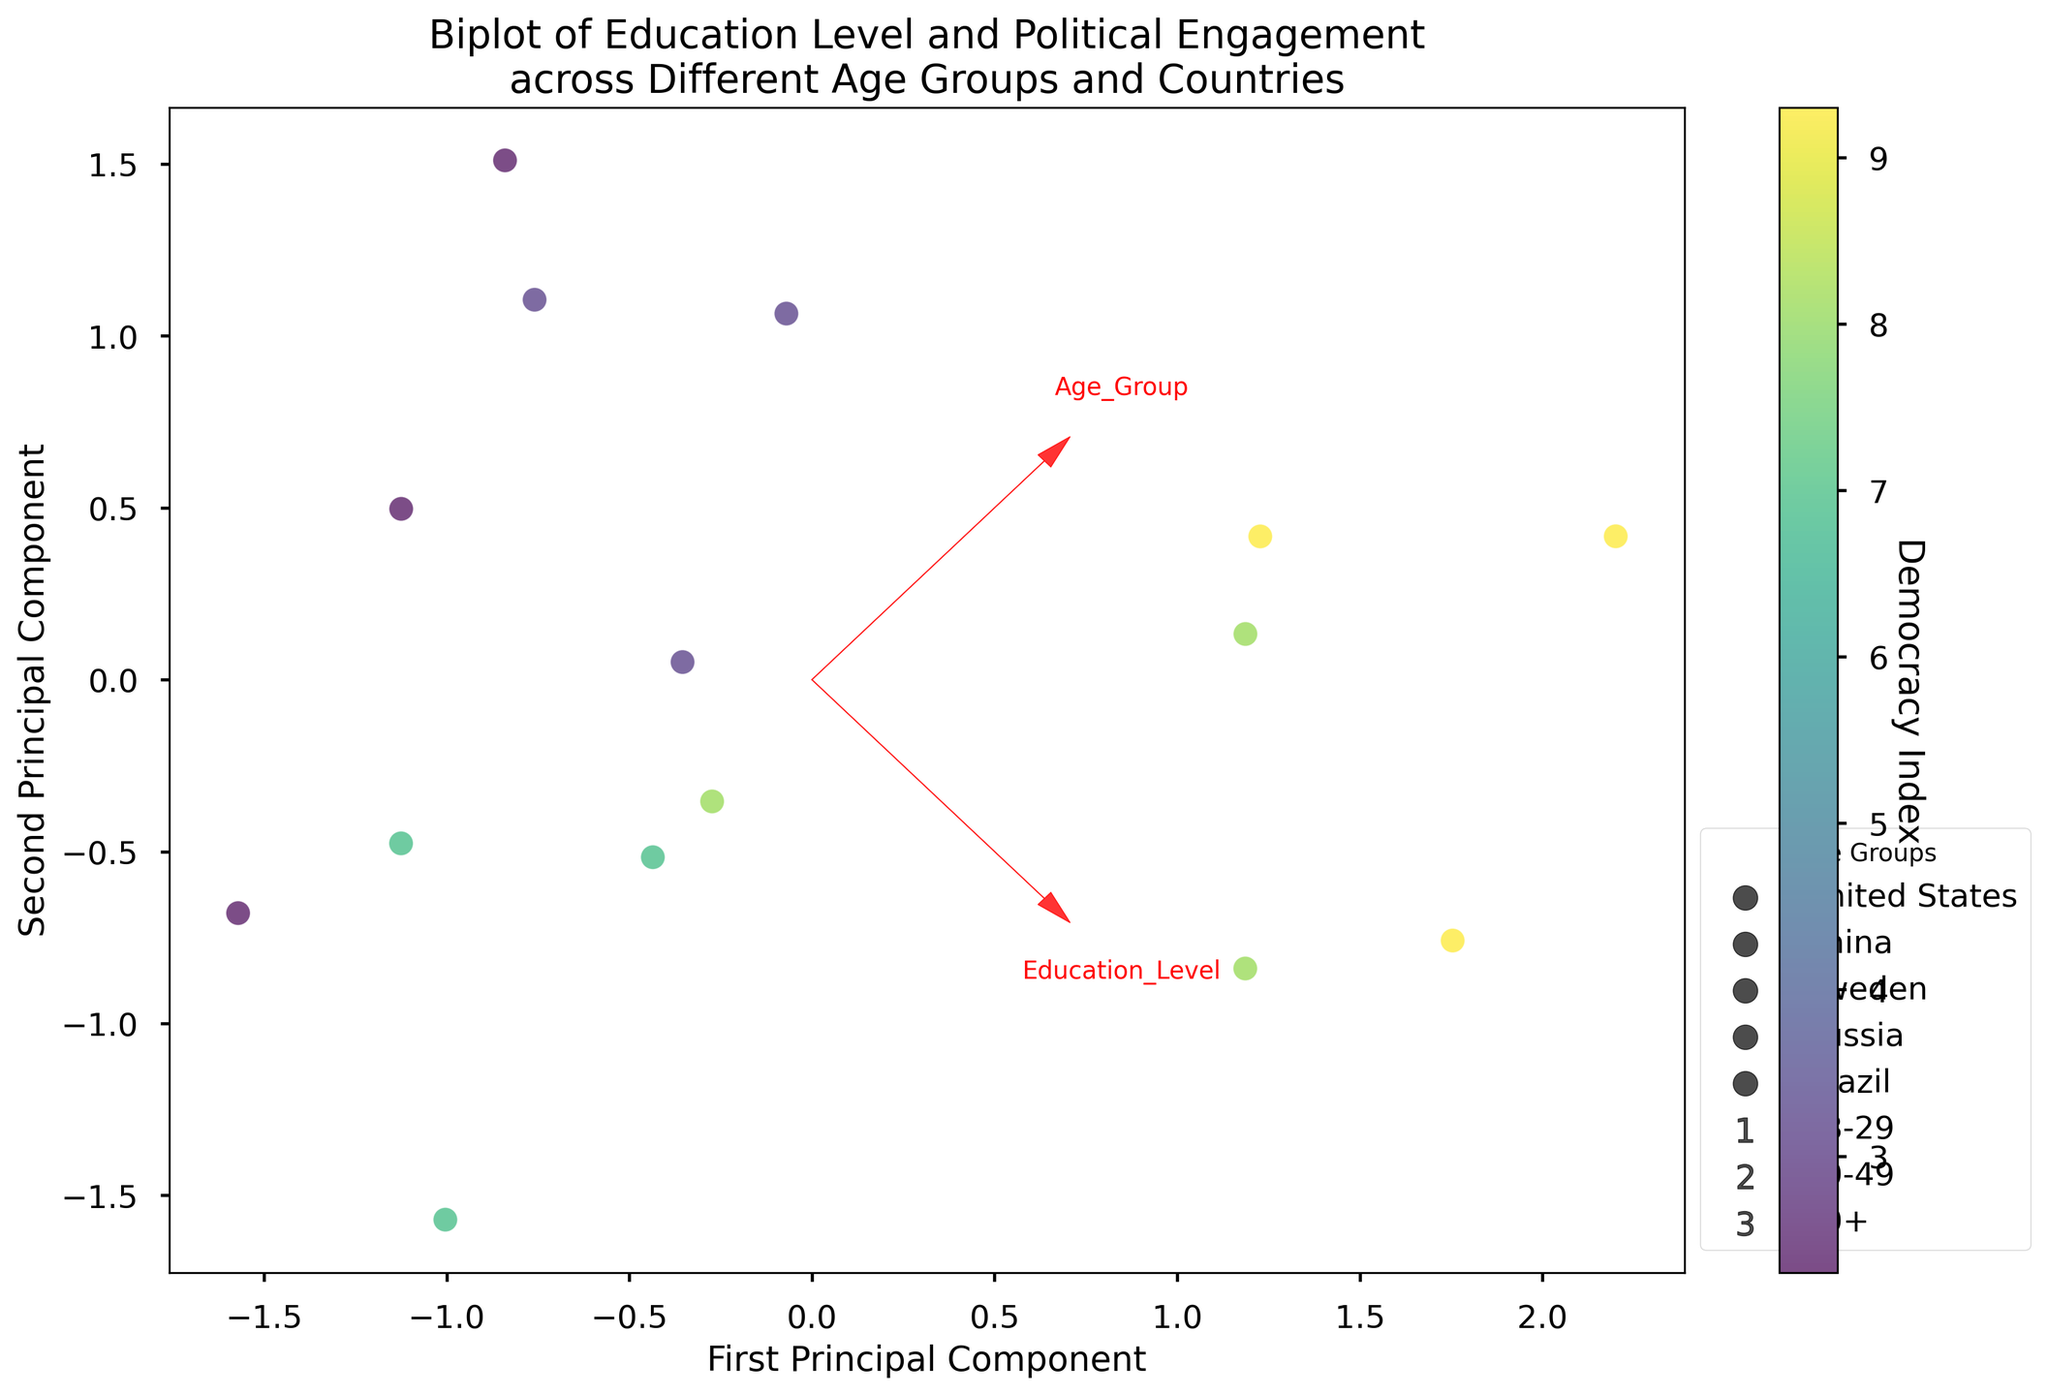What are the labels of the axes? The x-axis is labeled as the "First Principal Component," and the y-axis is labeled as the "Second Principal Component." These represent the two main components that summarize the data.
Answer: First Principal Component, Second Principal Component Which country has the highest political engagement among the 50+ age group? According to the color distribution, Sweden has the highest political engagement among the 50+ age group. This can be inferred from the Democracy Index color scale, where Sweden's data points tend to have higher political engagement values visibly.
Answer: Sweden How do political engagement levels of the 18-29 age group in China compare to those in the United States? By looking at both axes, the political engagement levels for the 18-29 age group in China (with a lower score on the Political_Engagement axis) are lower compared to those in the United States (higher score on the Political_Engagement axis).
Answer: Lower What does the direction of the arrow representing "Education Level" suggest in the biplot? The arrow for "Education Level" points to the right, indicating that increasing scores on the First Principal Component are associated with higher education levels. This suggests a positive relationship between the First Principal Component and education levels.
Answer: Positive relationship Which feature contributes more to the first principal component, Education Level or Political Engagement? The length and direction of the arrows help determine the contribution. The arrow for "Education Level" is more aligned with the First Principal Component axis and is longer than the "Political Engagement" arrow, indicating that "Education Level" contributes more to the first principal component.
Answer: Education Level Compare the political engagement levels for the age group 30-49 in Russia and Brazil. To compare these levels, locate the data points for these countries in the 30-49 age group. Russia's 30-49 data point is lower on the Political_Engagement axis than Brazil's, implying lower engagement.
Answer: Brazil has higher Which country has the widest spread in education levels across the different age groups? The spread in education levels can be observed by how dispersed the data points for different age groups are along the "Education Level" axis for each country. The United States shows a significant spread, with differences in the positioned components across age groups.
Answer: United States In what direction are the data points of non-democratic countries mostly spread? Identifying non-democratic countries by their colors (lower Democracy Index values), these points are mostly spread in the negative direction along the Second Principal Component axis, which is associated with lower political engagement scores.
Answer: Negative direction on Second Principal Component axis Is there a general trend between Democracy Index and political engagement in the figure? Observing the color gradient representing the Democracy Index, countries with higher Democracy Index values also show higher positions on the Political_Engagement axis, suggesting a positive trend where higher Democracy Index corresponds to higher political engagement.
Answer: Positive trend 